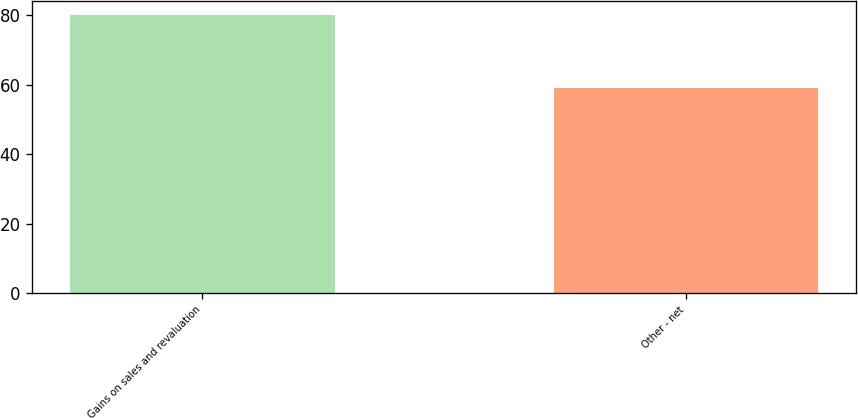<chart> <loc_0><loc_0><loc_500><loc_500><bar_chart><fcel>Gains on sales and revaluation<fcel>Other - net<nl><fcel>80<fcel>59<nl></chart> 